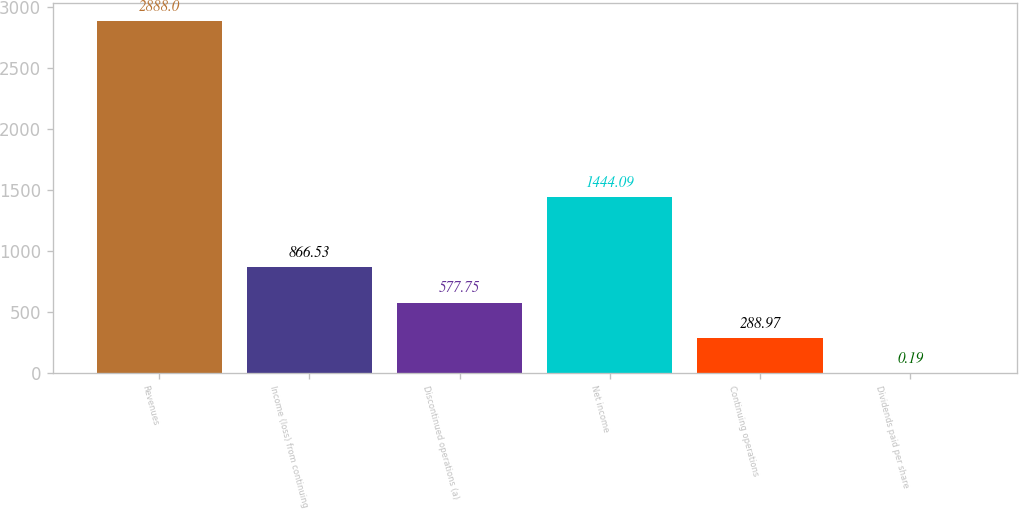<chart> <loc_0><loc_0><loc_500><loc_500><bar_chart><fcel>Revenues<fcel>Income (loss) from continuing<fcel>Discontinued operations (a)<fcel>Net income<fcel>Continuing operations<fcel>Dividends paid per share<nl><fcel>2888<fcel>866.53<fcel>577.75<fcel>1444.09<fcel>288.97<fcel>0.19<nl></chart> 